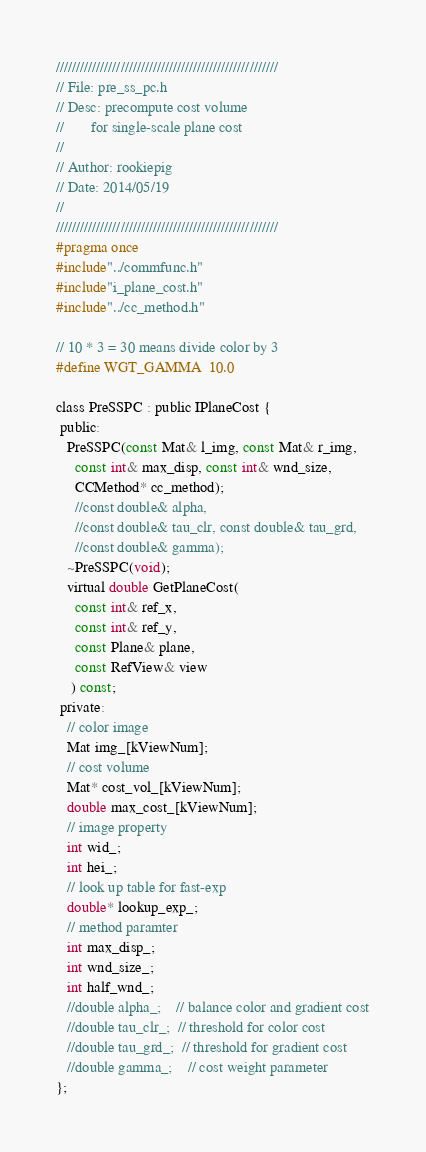<code> <loc_0><loc_0><loc_500><loc_500><_C_>///////////////////////////////////////////////////////
// File: pre_ss_pc.h
// Desc: precompute cost volume
//       for single-scale plane cost
//
// Author: rookiepig
// Date: 2014/05/19
//
///////////////////////////////////////////////////////
#pragma once
#include"../commfunc.h"
#include"i_plane_cost.h"
#include"../cc_method.h"

// 10 * 3 = 30 means divide color by 3
#define WGT_GAMMA  10.0

class PreSSPC : public IPlaneCost {
 public:
   PreSSPC(const Mat& l_img, const Mat& r_img,
     const int& max_disp, const int& wnd_size,
     CCMethod* cc_method);
     //const double& alpha,
     //const double& tau_clr, const double& tau_grd,
     //const double& gamma);
   ~PreSSPC(void);
   virtual double GetPlaneCost(
     const int& ref_x,
     const int& ref_y,
     const Plane& plane,
     const RefView& view
    ) const;
 private:
   // color image
   Mat img_[kViewNum];
   // cost volume
   Mat* cost_vol_[kViewNum];
   double max_cost_[kViewNum];
   // image property
   int wid_;
   int hei_;
   // look up table for fast-exp
   double* lookup_exp_;
   // method paramter
   int max_disp_;
   int wnd_size_;
   int half_wnd_;
   //double alpha_;    // balance color and gradient cost
   //double tau_clr_;  // threshold for color cost
   //double tau_grd_;  // threshold for gradient cost
   //double gamma_;    // cost weight parameter
};
</code> 